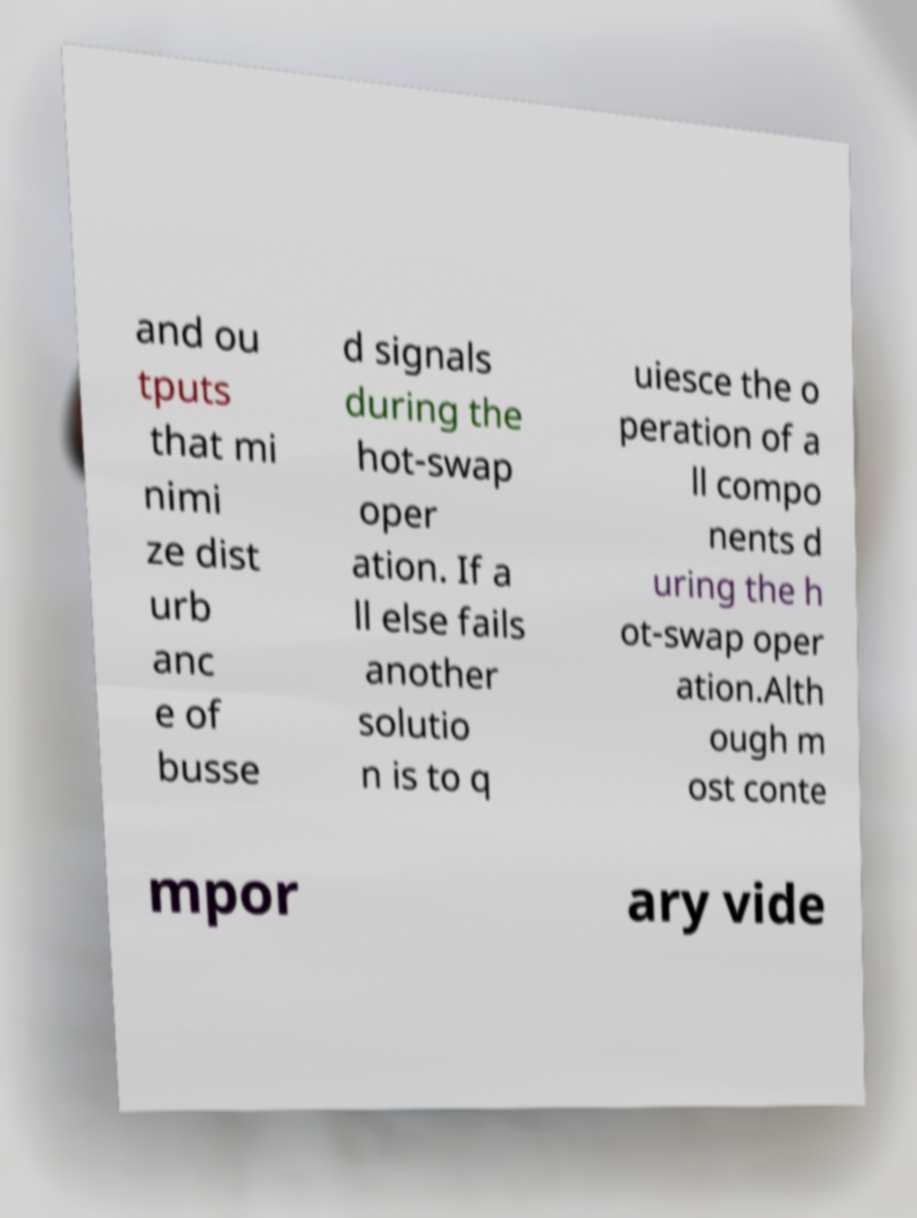Could you assist in decoding the text presented in this image and type it out clearly? and ou tputs that mi nimi ze dist urb anc e of busse d signals during the hot-swap oper ation. If a ll else fails another solutio n is to q uiesce the o peration of a ll compo nents d uring the h ot-swap oper ation.Alth ough m ost conte mpor ary vide 